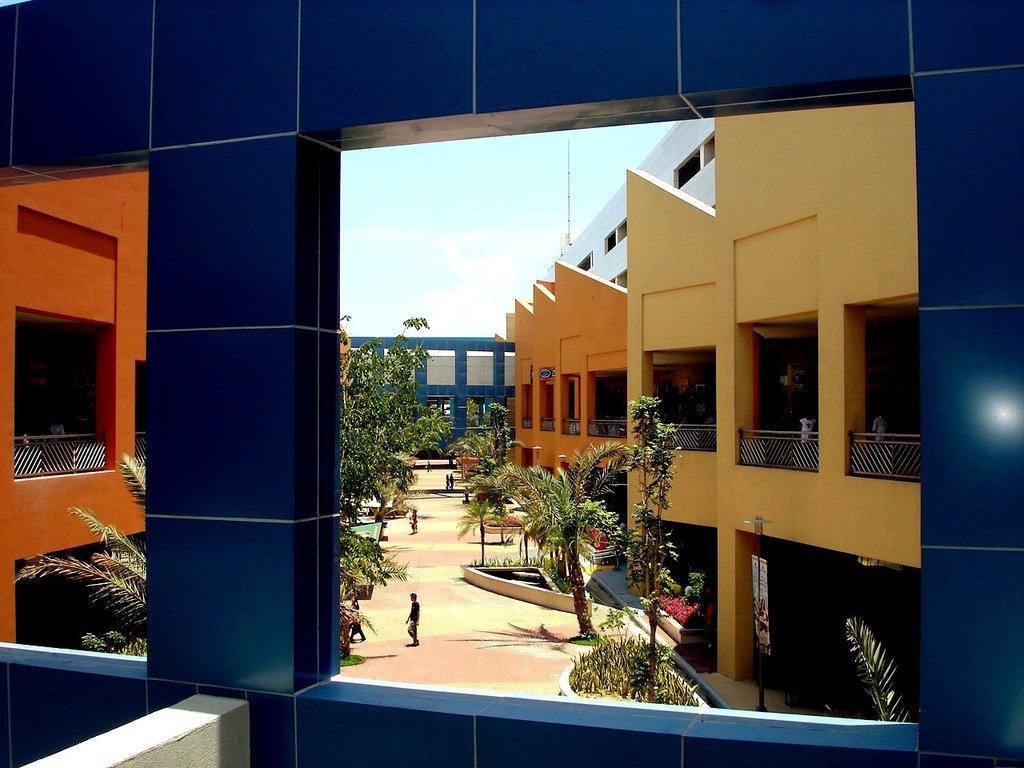Could you give a brief overview of what you see in this image? In the image we can see the buildings and trees. Here we can see the fence, footpath and the sky. We can see there are even people walking and they are wearing clothes. 